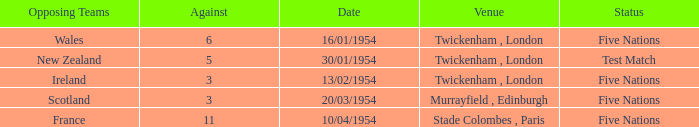What was the venue for the game played on 16/01/1954, when the against was more than 3? Twickenham , London. 